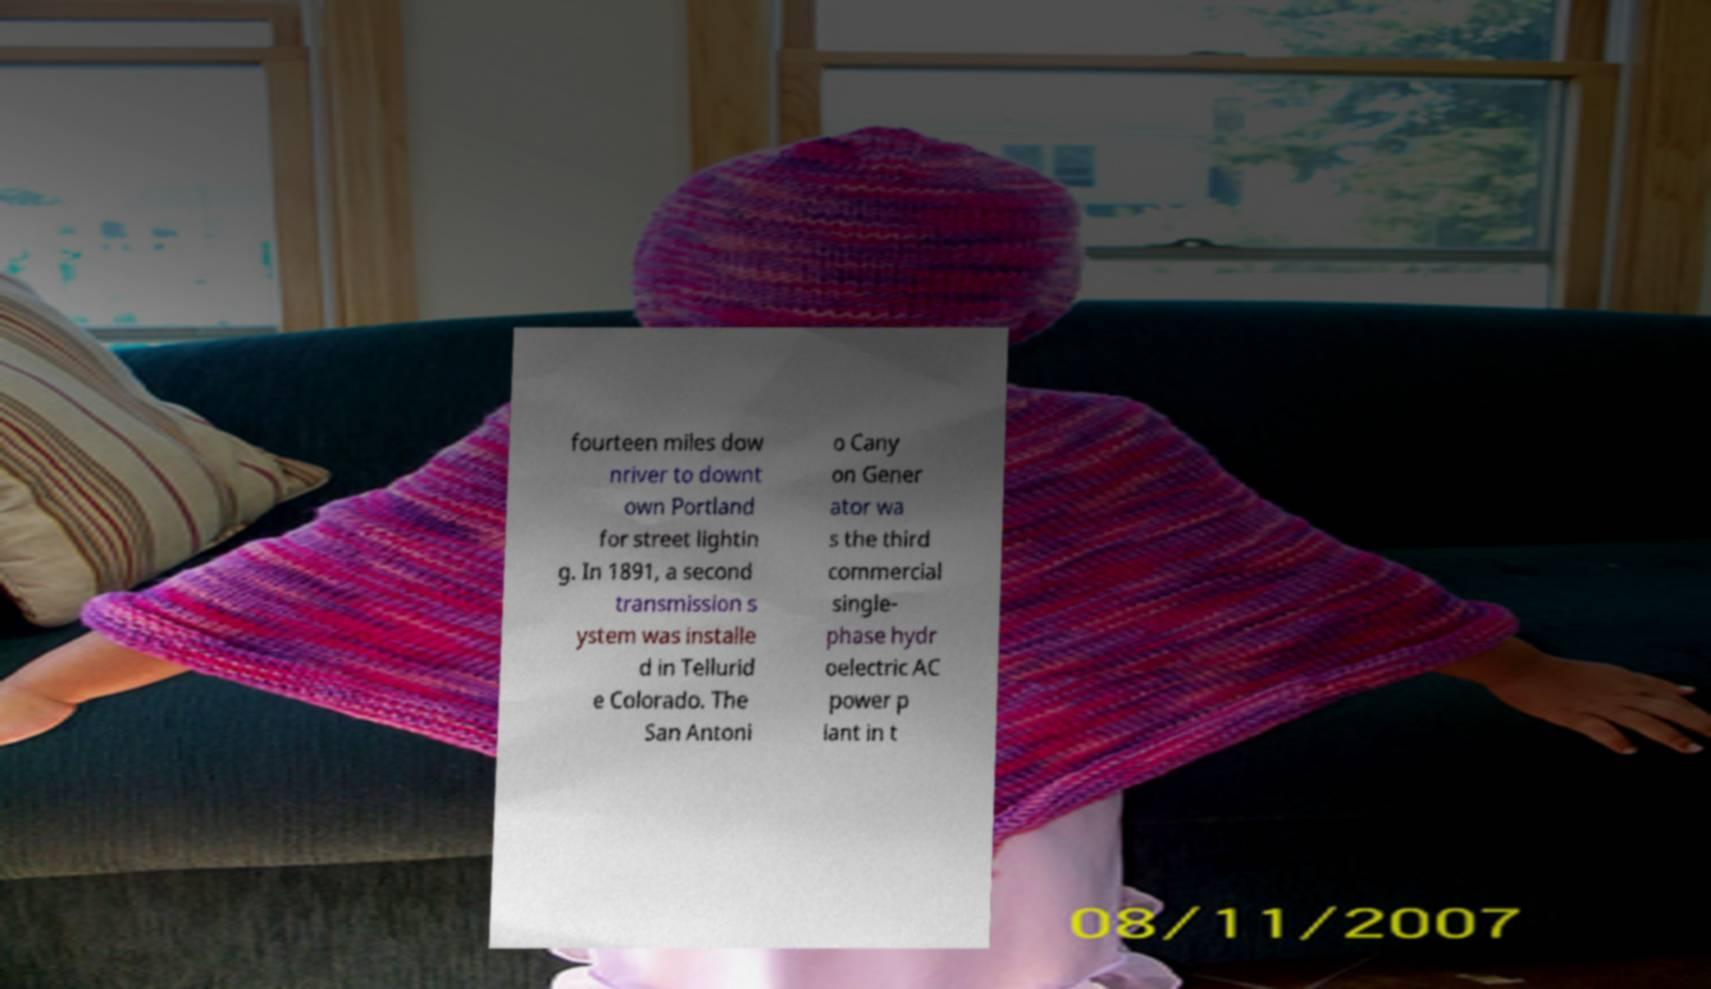Please identify and transcribe the text found in this image. fourteen miles dow nriver to downt own Portland for street lightin g. In 1891, a second transmission s ystem was installe d in Tellurid e Colorado. The San Antoni o Cany on Gener ator wa s the third commercial single- phase hydr oelectric AC power p lant in t 